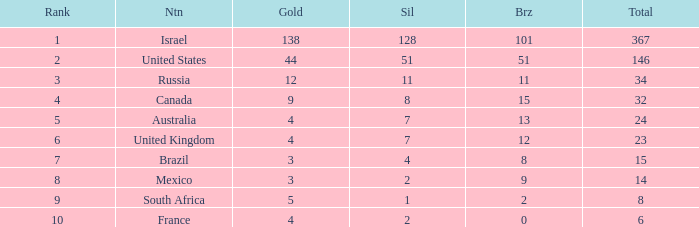What is the gold medal count for the country with a total greater than 32 and more than 128 silvers? None. 